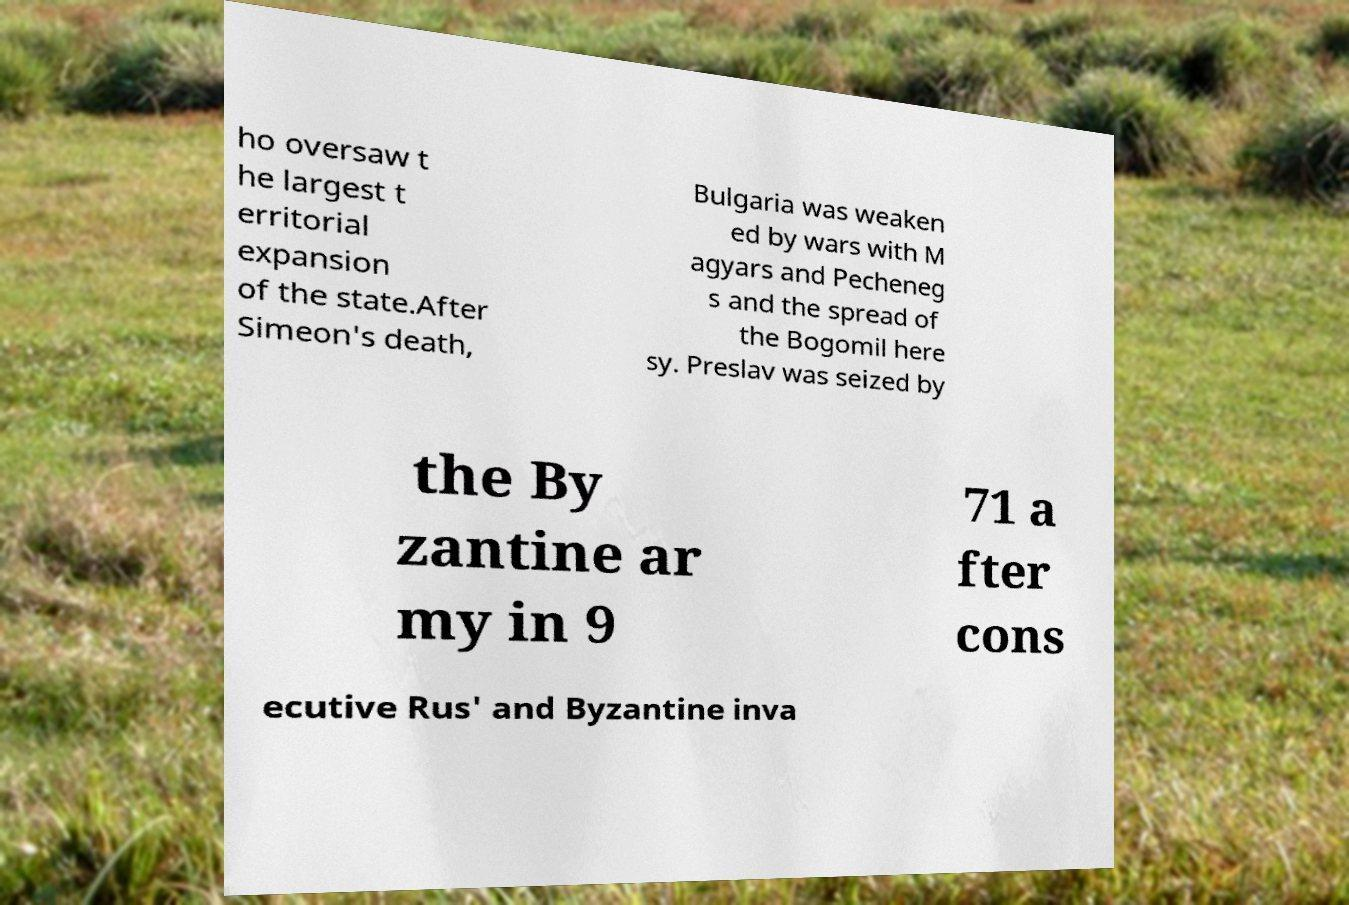What messages or text are displayed in this image? I need them in a readable, typed format. ho oversaw t he largest t erritorial expansion of the state.After Simeon's death, Bulgaria was weaken ed by wars with M agyars and Pecheneg s and the spread of the Bogomil here sy. Preslav was seized by the By zantine ar my in 9 71 a fter cons ecutive Rus' and Byzantine inva 